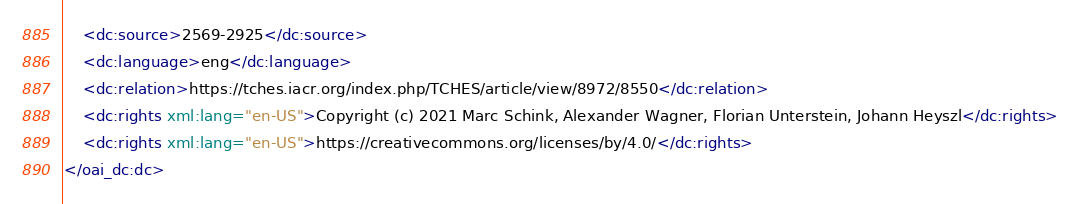Convert code to text. <code><loc_0><loc_0><loc_500><loc_500><_XML_>	<dc:source>2569-2925</dc:source>
	<dc:language>eng</dc:language>
	<dc:relation>https://tches.iacr.org/index.php/TCHES/article/view/8972/8550</dc:relation>
	<dc:rights xml:lang="en-US">Copyright (c) 2021 Marc Schink, Alexander Wagner, Florian Unterstein, Johann Heyszl</dc:rights>
	<dc:rights xml:lang="en-US">https://creativecommons.org/licenses/by/4.0/</dc:rights>
</oai_dc:dc></code> 